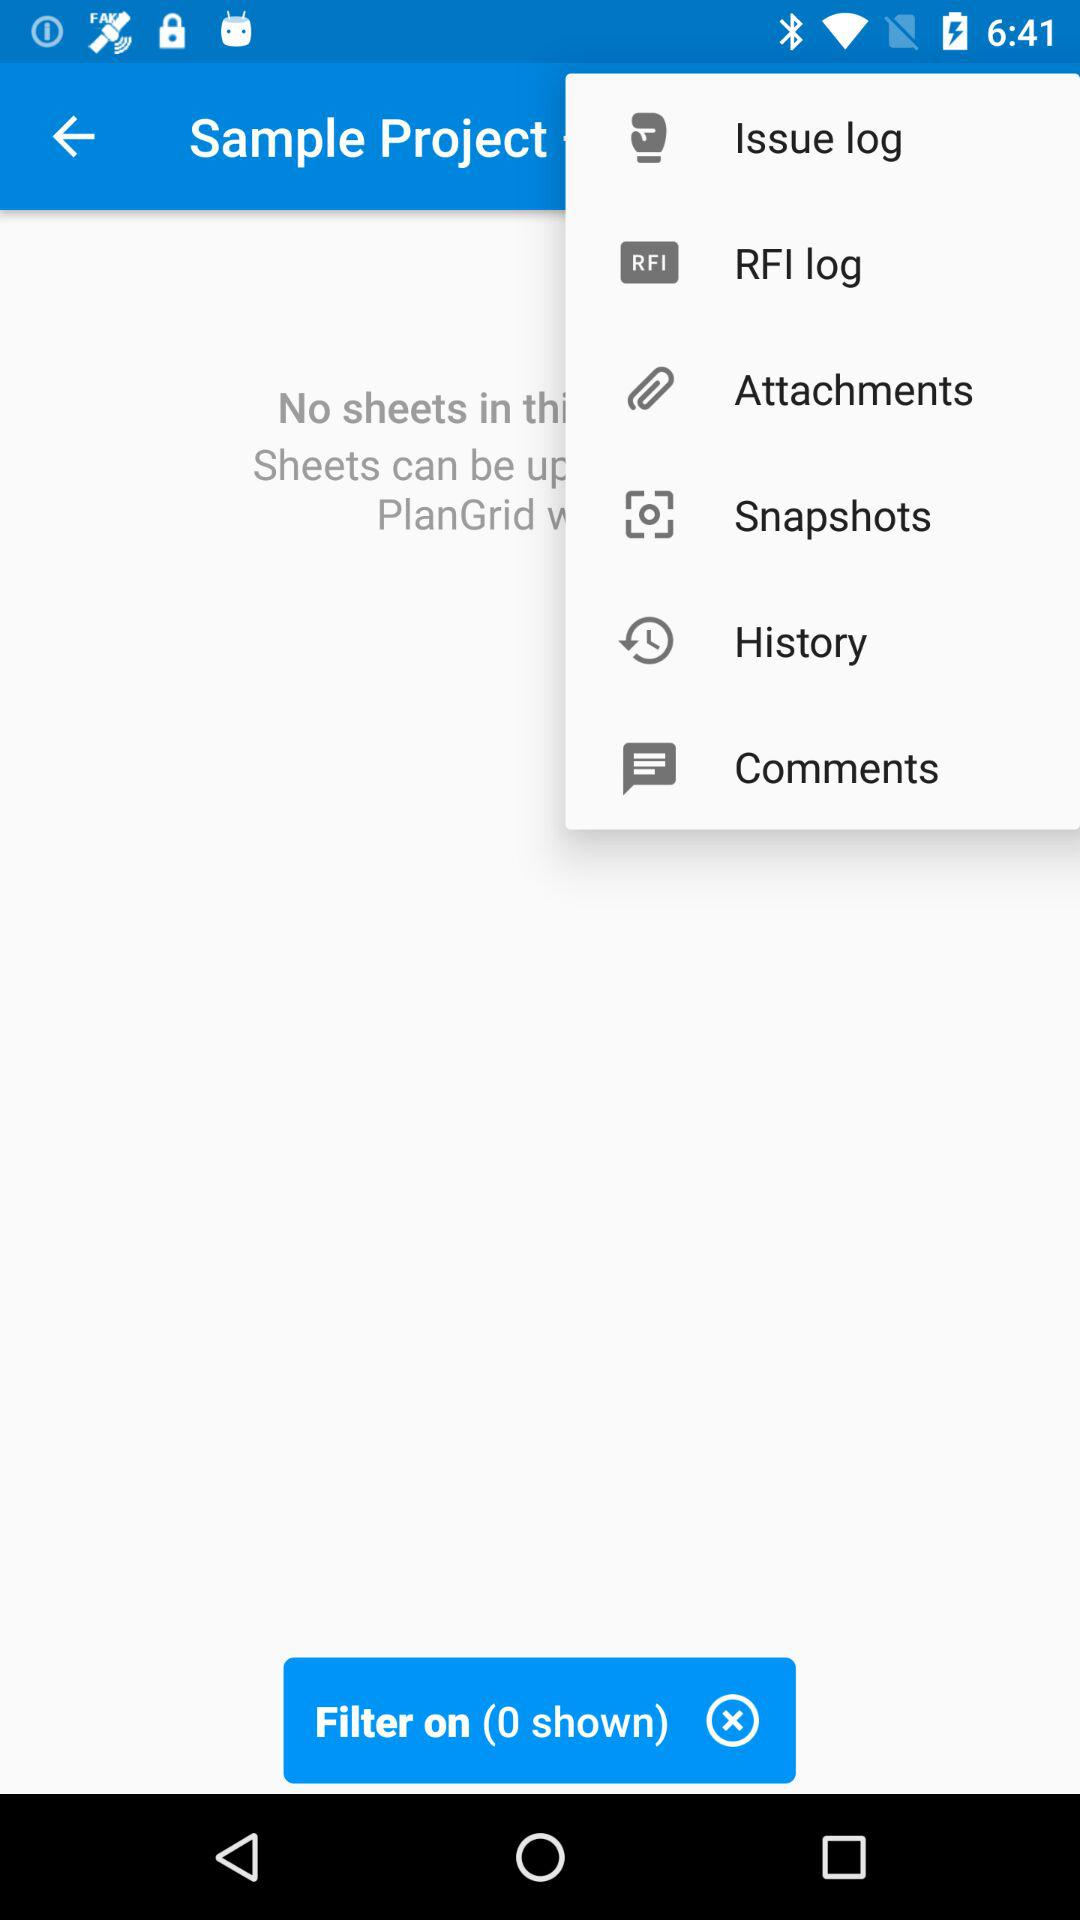How many "Filter on" in total are shown there? There is zero "Filter on" displayed. 